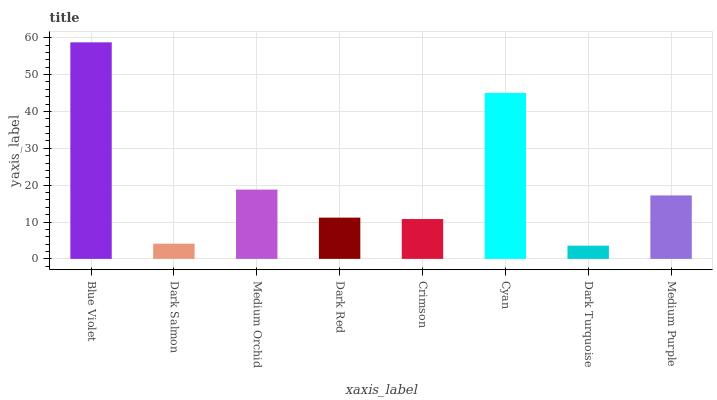Is Dark Turquoise the minimum?
Answer yes or no. Yes. Is Blue Violet the maximum?
Answer yes or no. Yes. Is Dark Salmon the minimum?
Answer yes or no. No. Is Dark Salmon the maximum?
Answer yes or no. No. Is Blue Violet greater than Dark Salmon?
Answer yes or no. Yes. Is Dark Salmon less than Blue Violet?
Answer yes or no. Yes. Is Dark Salmon greater than Blue Violet?
Answer yes or no. No. Is Blue Violet less than Dark Salmon?
Answer yes or no. No. Is Medium Purple the high median?
Answer yes or no. Yes. Is Dark Red the low median?
Answer yes or no. Yes. Is Cyan the high median?
Answer yes or no. No. Is Dark Salmon the low median?
Answer yes or no. No. 